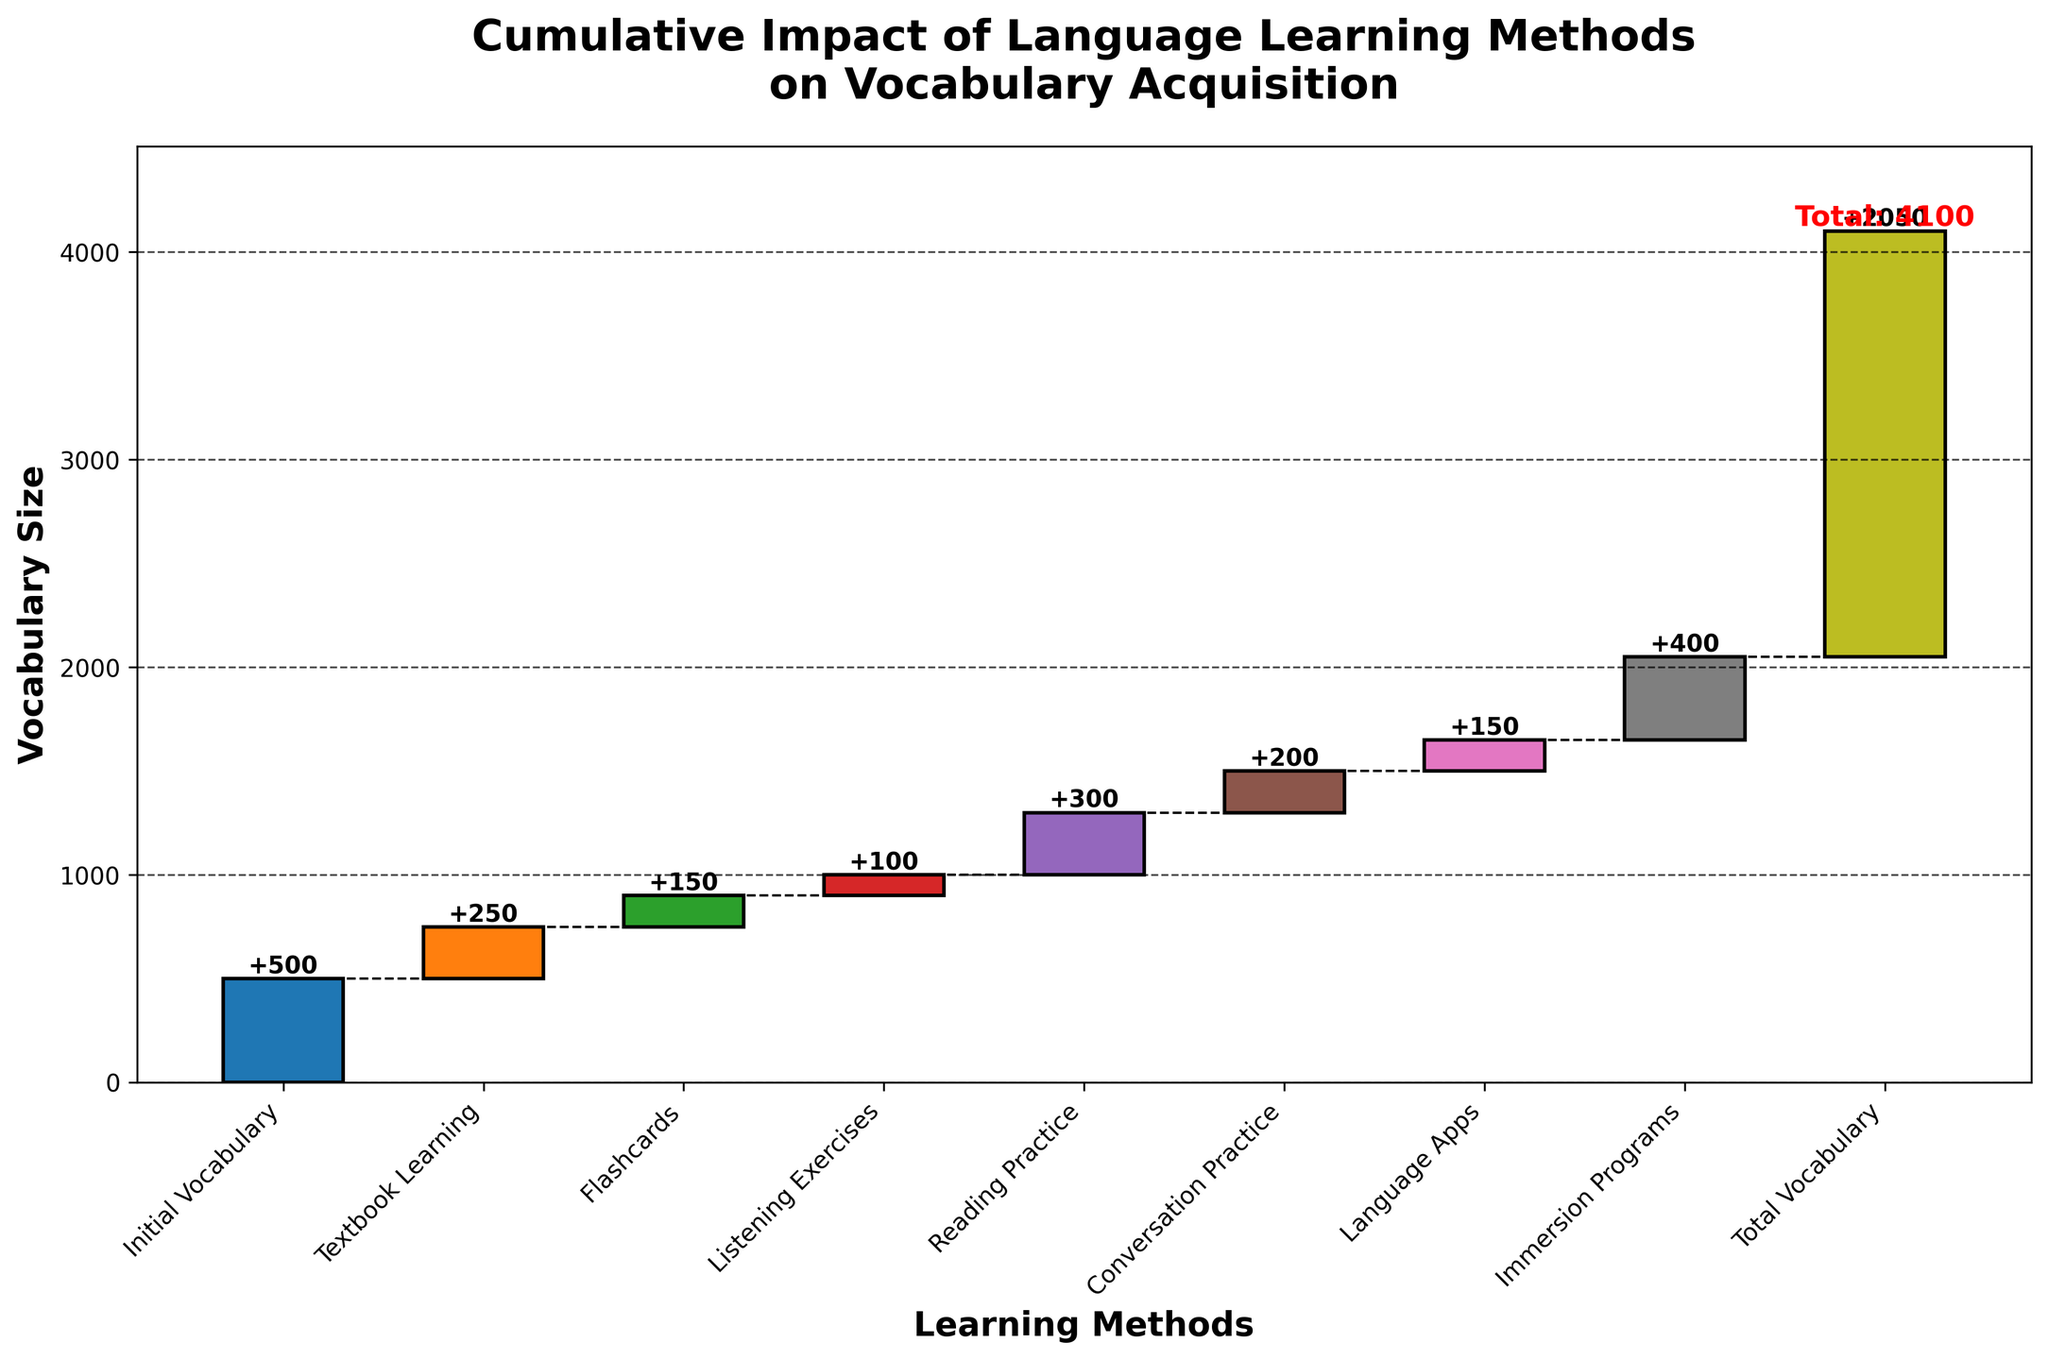What is the title of the chart? The title of the chart is prominently displayed at the top. It reads "Cumulative Impact of Language Learning Methods on Vocabulary Acquisition".
Answer: Cumulative Impact of Language Learning Methods on Vocabulary Acquisition How many learning methods are analyzed in the chart? The x-axis of the chart lists the learning methods being analyzed. By counting the labels on the x-axis, we can determine the number of methods.
Answer: 8 Which learning method contributed the most to vocabulary increase? Each bar represents a learning method and its contribution to vocabulary increase. The method with the longest bar contributes the most.
Answer: Immersion Programs What is the total vocabulary size achieved according to the chart? The final bar on the right side of the chart indicates the cumulative vocabulary size. It is labeled with the total value.
Answer: 2050 How much did Textbook Learning increase vocabulary size? The height of the bar corresponding to "Textbook Learning" indicates its contribution to vocabulary increase, which is clearly marked on the bar.
Answer: 250 How much vocabulary did Listening Exercises and Flashcards together add? Listening Exercises contributed 100, and Flashcards contributed 150. Adding these numbers gives the total vocabulary increase from both methods.
Answer: 250 Which learning method had a greater impact on vocabulary acquisition, Reading Practice or Language Apps? By comparing the heights of the bars for "Reading Practice" and "Language Apps", we can see which bar is taller and thus has a greater impact.
Answer: Reading Practice What is the cumulative vocabulary size after Conversation Practice? By following the connecting lines and the cumulative labels on the bars up to "Conversation Practice", we can determine the cumulative vocabulary size at that point.
Answer: 1500 What is the average vocabulary increase per learning method? The total cumulative vocabulary increase from all methods is 1550 (2050 - 500). Dividing this by the number of methods (8), we get the average increase per method.
Answer: 193.75 How much more vocabulary is gained from Immersion Programs compared to Flashcards? The vocabulary increase from Immersion Programs is 400, and from Flashcards is 150. Subtracting these values gives the difference.
Answer: 250 